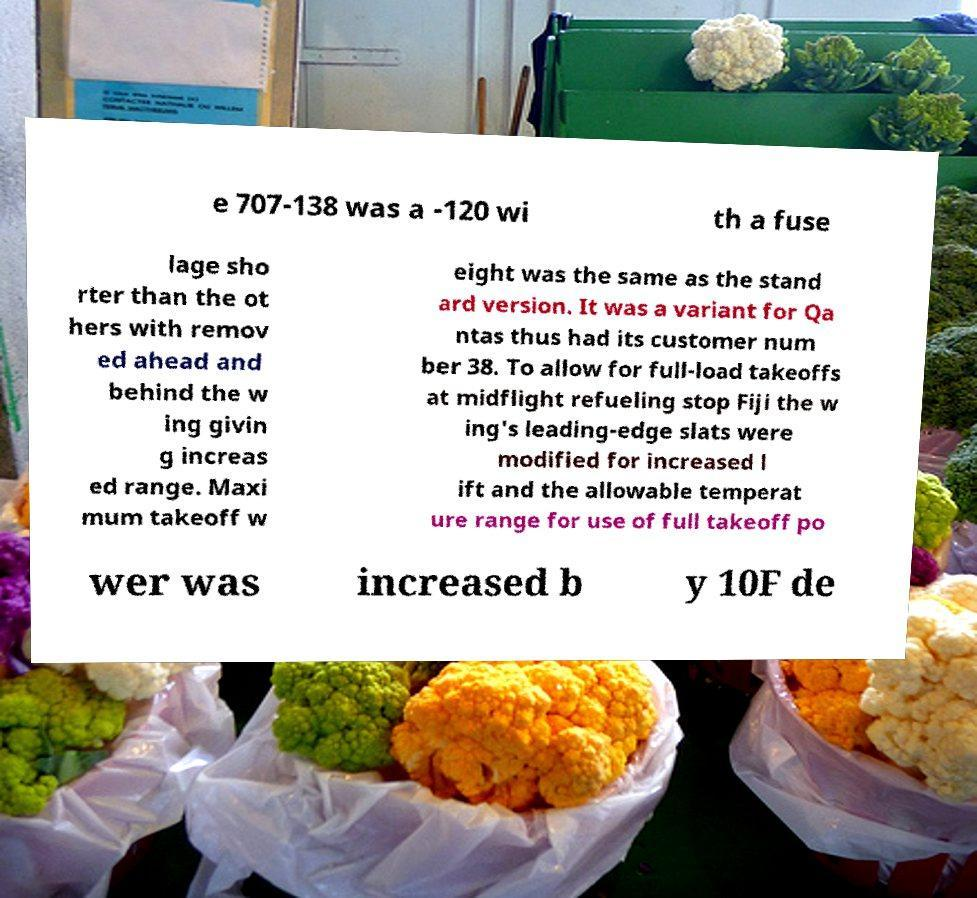For documentation purposes, I need the text within this image transcribed. Could you provide that? e 707-138 was a -120 wi th a fuse lage sho rter than the ot hers with remov ed ahead and behind the w ing givin g increas ed range. Maxi mum takeoff w eight was the same as the stand ard version. It was a variant for Qa ntas thus had its customer num ber 38. To allow for full-load takeoffs at midflight refueling stop Fiji the w ing's leading-edge slats were modified for increased l ift and the allowable temperat ure range for use of full takeoff po wer was increased b y 10F de 